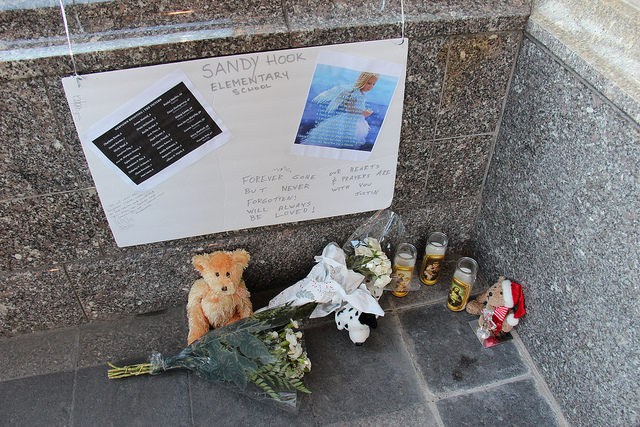Extract all visible text content from this image. SANDY HOOK ELEMENTARY SCHOOL FOREVER YOU WITH PRAYERS ARE BEATS OUR GONE NEVER BUT BE WILL FORGETTENS LOVER ALWAYS 